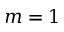<formula> <loc_0><loc_0><loc_500><loc_500>m = 1</formula> 